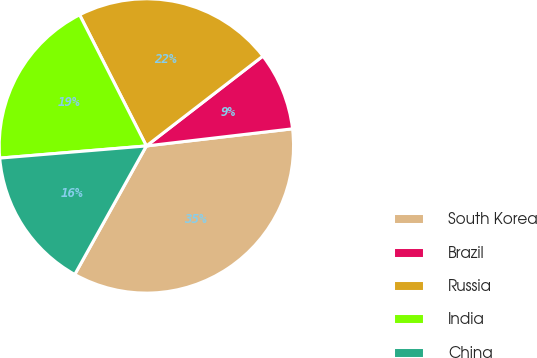Convert chart to OTSL. <chart><loc_0><loc_0><loc_500><loc_500><pie_chart><fcel>South Korea<fcel>Brazil<fcel>Russia<fcel>India<fcel>China<nl><fcel>34.95%<fcel>8.6%<fcel>22.04%<fcel>18.82%<fcel>15.59%<nl></chart> 